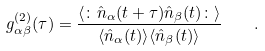Convert formula to latex. <formula><loc_0><loc_0><loc_500><loc_500>g ^ { ( 2 ) } _ { \alpha \beta } ( \tau ) = \frac { \langle \colon \hat { n } _ { \alpha } ( t + \tau ) \hat { n } _ { \beta } ( t ) \colon \rangle } { \langle \hat { n } _ { \alpha } ( t ) \rangle \langle \hat { n } _ { \beta } ( t ) \rangle } \quad .</formula> 